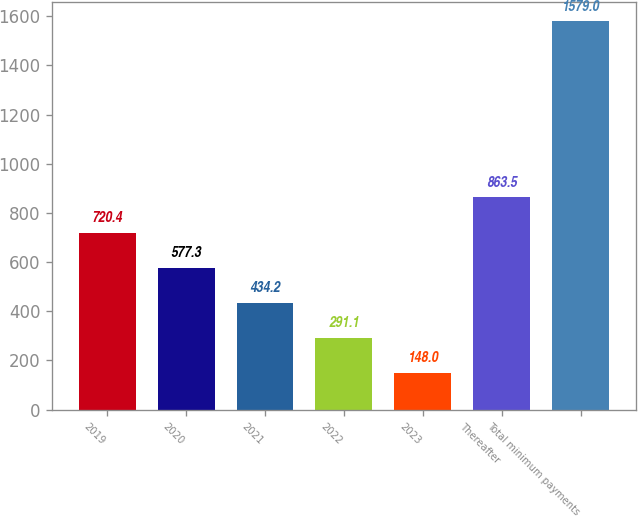Convert chart to OTSL. <chart><loc_0><loc_0><loc_500><loc_500><bar_chart><fcel>2019<fcel>2020<fcel>2021<fcel>2022<fcel>2023<fcel>Thereafter<fcel>Total minimum payments<nl><fcel>720.4<fcel>577.3<fcel>434.2<fcel>291.1<fcel>148<fcel>863.5<fcel>1579<nl></chart> 